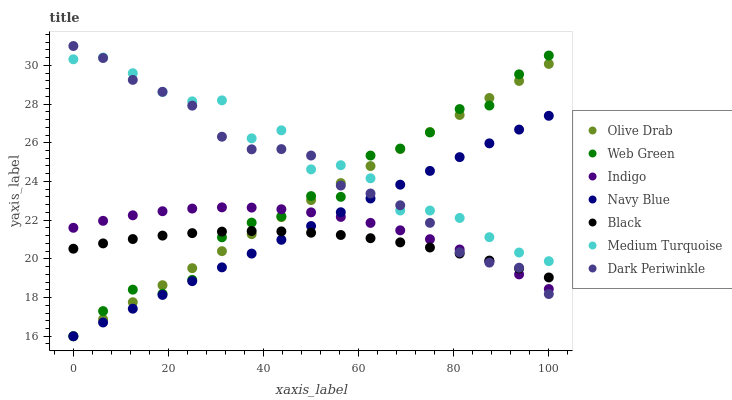Does Black have the minimum area under the curve?
Answer yes or no. Yes. Does Medium Turquoise have the maximum area under the curve?
Answer yes or no. Yes. Does Navy Blue have the minimum area under the curve?
Answer yes or no. No. Does Navy Blue have the maximum area under the curve?
Answer yes or no. No. Is Navy Blue the smoothest?
Answer yes or no. Yes. Is Medium Turquoise the roughest?
Answer yes or no. Yes. Is Web Green the smoothest?
Answer yes or no. No. Is Web Green the roughest?
Answer yes or no. No. Does Navy Blue have the lowest value?
Answer yes or no. Yes. Does Black have the lowest value?
Answer yes or no. No. Does Dark Periwinkle have the highest value?
Answer yes or no. Yes. Does Navy Blue have the highest value?
Answer yes or no. No. Is Indigo less than Medium Turquoise?
Answer yes or no. Yes. Is Medium Turquoise greater than Black?
Answer yes or no. Yes. Does Navy Blue intersect Indigo?
Answer yes or no. Yes. Is Navy Blue less than Indigo?
Answer yes or no. No. Is Navy Blue greater than Indigo?
Answer yes or no. No. Does Indigo intersect Medium Turquoise?
Answer yes or no. No. 